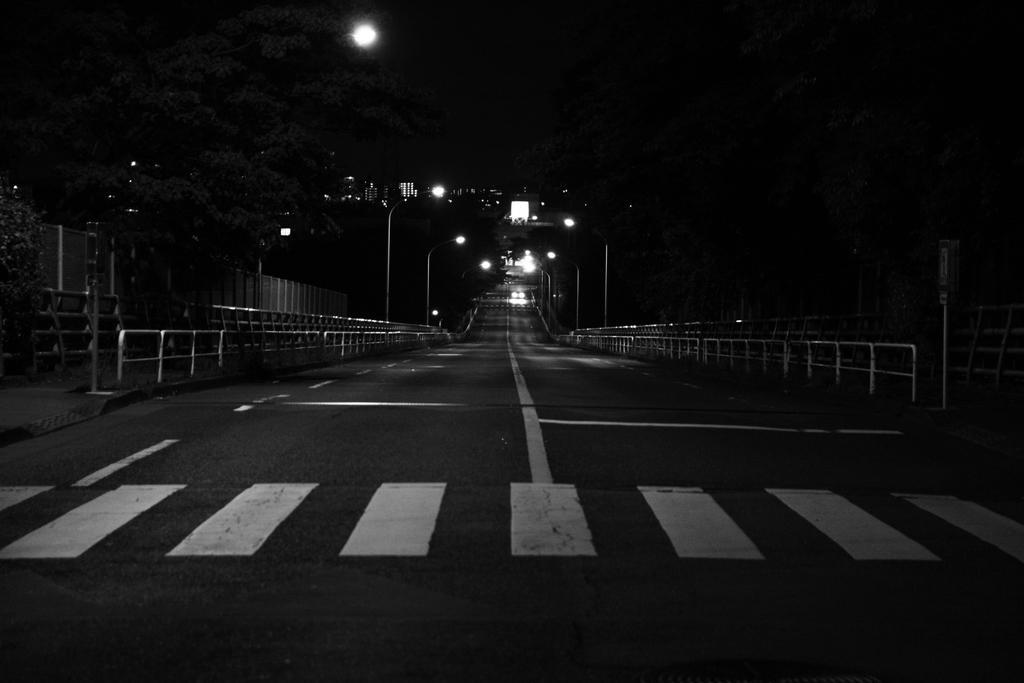Describe this image in one or two sentences. At the bottom of the picture, we see the road. On either side of the road, we see an iron railing and street lights. There are trees and buildings in the background. At the top of the picture, we see the moon. In the background, it is black in color. This picture is clicked in the dark. 